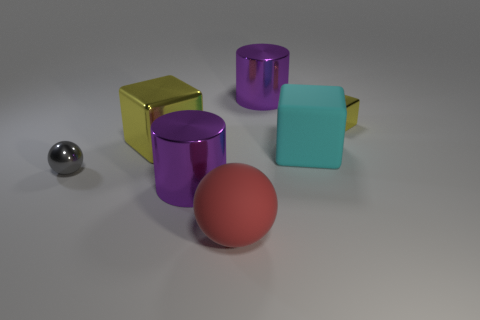Is the number of red matte things that are left of the large shiny block greater than the number of blue shiny blocks? no 